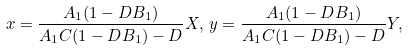<formula> <loc_0><loc_0><loc_500><loc_500>x = \frac { A _ { 1 } ( 1 - D B _ { 1 } ) } { A _ { 1 } C ( 1 - D B _ { 1 } ) - D } X , \, y = \frac { A _ { 1 } ( 1 - D B _ { 1 } ) } { A _ { 1 } C ( 1 - D B _ { 1 } ) - D } Y ,</formula> 